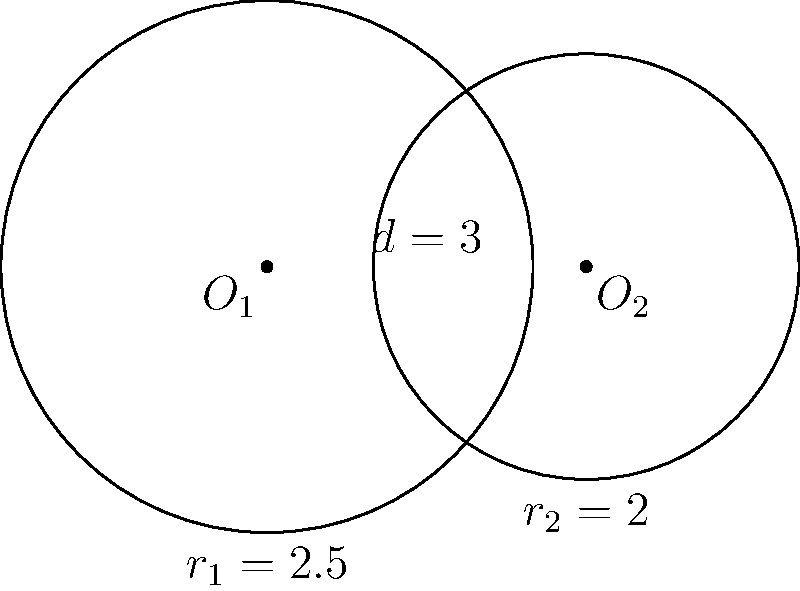As the organizer of a rival convention, you're planning a unique seating arrangement using overlapping circular stages. Two circular stages with radii $r_1 = 2.5$ meters and $r_2 = 2$ meters are placed such that their centers are 3 meters apart. Calculate the area of the overlapping region between these two stages, rounded to two decimal places. This will determine the number of VIP seats you can offer in this exclusive area. To solve this problem, we'll use the formula for the area of intersection of two circles. Let's approach this step-by-step:

1) First, we need to calculate the distance $a$ from the center of each circle to the line of intersection:

   $a_1 = \frac{r_1^2 - r_2^2 + d^2}{2d}$ for the larger circle
   $a_2 = d - a_1$ for the smaller circle

   Where $d$ is the distance between the centers (3 meters)

2) Calculate $a_1$:
   $a_1 = \frac{2.5^2 - 2^2 + 3^2}{2(3)} = \frac{6.25 - 4 + 9}{6} = \frac{11.25}{6} = 1.875$ meters

3) Calculate $a_2$:
   $a_2 = 3 - 1.875 = 1.125$ meters

4) Now, we can calculate the central angles $\theta_1$ and $\theta_2$:

   $\theta_1 = 2 \arccos(\frac{a_1}{r_1}) = 2 \arccos(\frac{1.875}{2.5}) = 2.0944$ radians
   $\theta_2 = 2 \arccos(\frac{a_2}{r_2}) = 2 \arccos(\frac{1.125}{2}) = 2.4981$ radians

5) The area of intersection is given by:

   $A = r_1^2(\frac{\theta_1}{2} - \frac{\sin\theta_1}{2}) + r_2^2(\frac{\theta_2}{2} - \frac{\sin\theta_2}{2})$

6) Substituting the values:

   $A = 2.5^2(\frac{2.0944}{2} - \frac{\sin(2.0944)}{2}) + 2^2(\frac{2.4981}{2} - \frac{\sin(2.4981)}{2})$
   
   $= 6.25(1.0472 - 0.4679) + 4(1.2491 - 0.5985)$
   
   $= 6.25(0.5793) + 4(0.6506)$
   
   $= 3.6206 + 2.6024$
   
   $= 6.2230$ square meters

7) Rounding to two decimal places: 6.22 square meters
Answer: 6.22 m² 